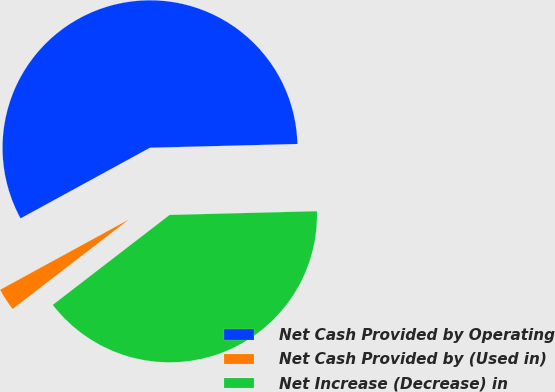<chart> <loc_0><loc_0><loc_500><loc_500><pie_chart><fcel>Net Cash Provided by Operating<fcel>Net Cash Provided by (Used in)<fcel>Net Increase (Decrease) in<nl><fcel>57.55%<fcel>2.49%<fcel>39.96%<nl></chart> 